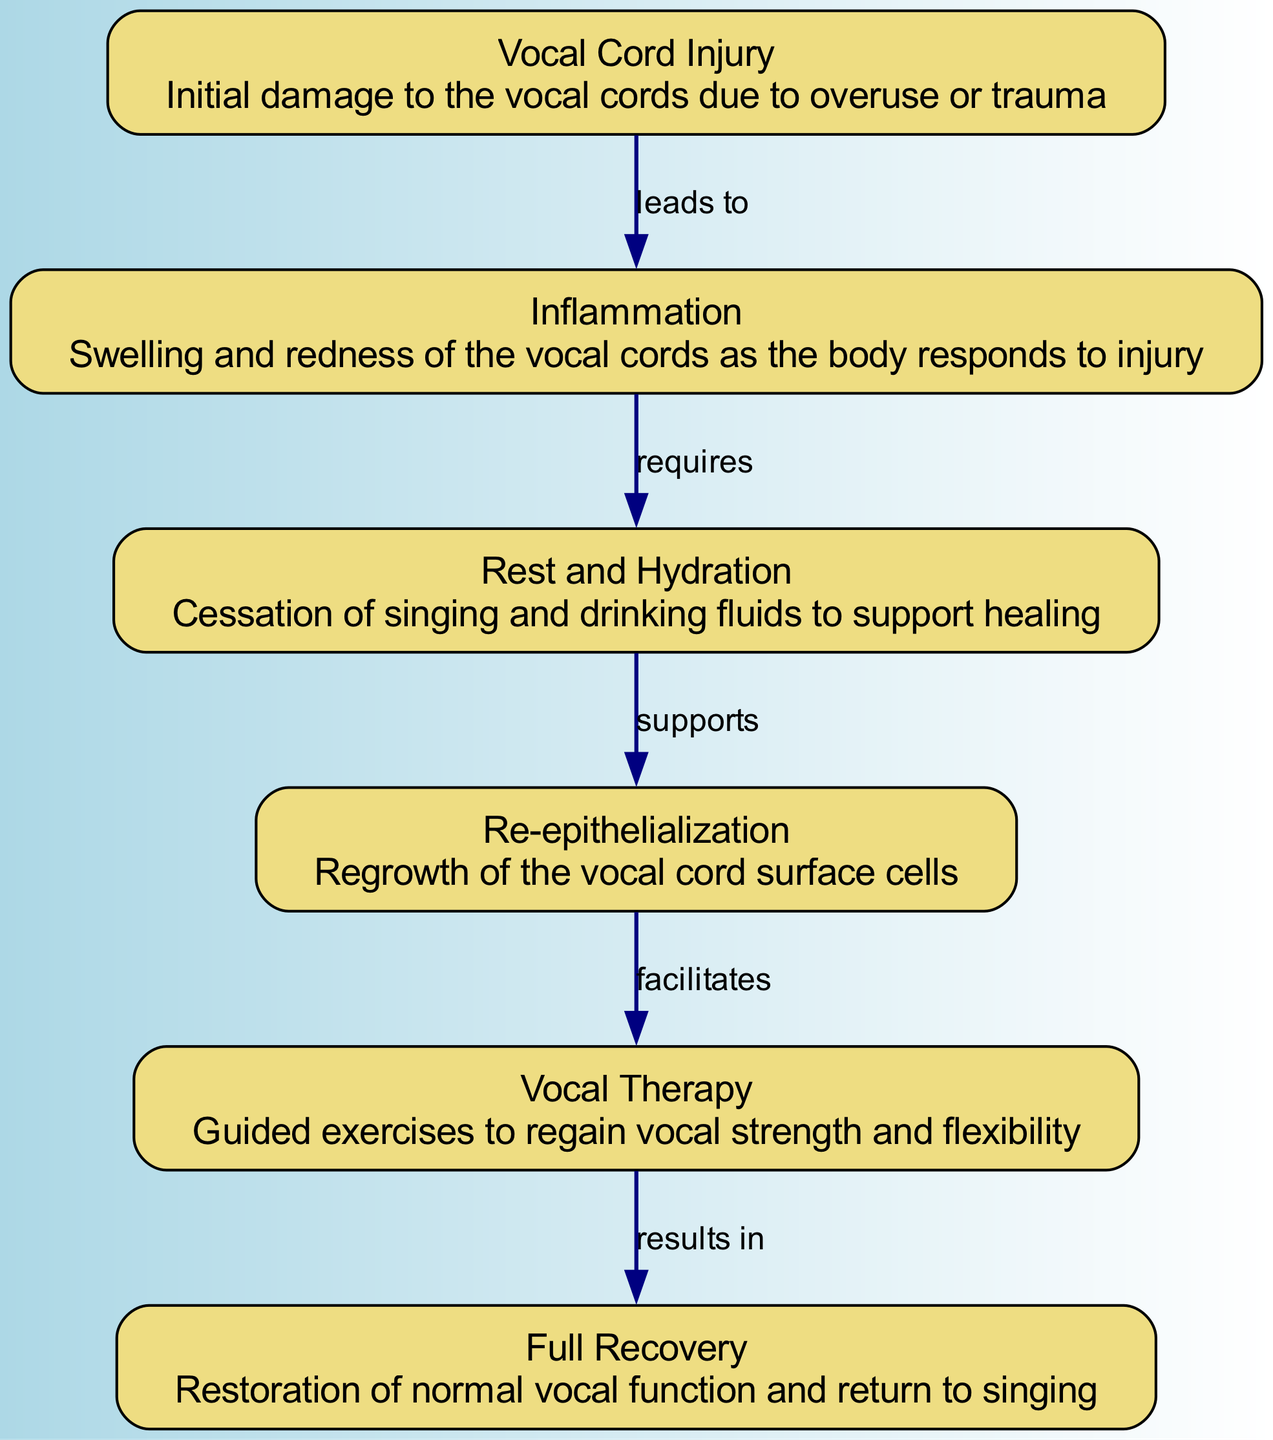What is the first stage of vocal cord healing? The first stage in the diagram is labeled "Vocal Cord Injury," which indicates the initial damage to the vocal cords caused by overuse or trauma.
Answer: Vocal Cord Injury What stage follows Inflammation? According to the diagram, Inflammation leads to the next stage listed, which is "Rest and Hydration."
Answer: Rest and Hydration How many total stages are represented in this diagram? There are six nodes present in the diagram, each representing a different stage in the healing process.
Answer: 6 What type of therapy is recommended after Re-epithelialization? The diagram indicates that after Re-epithelialization, the next stage involves "Vocal Therapy," which includes guided exercises to regain vocal strength and flexibility.
Answer: Vocal Therapy What supports the transition from Rest and Hydration to Re-epithelialization? The diagram shows that Rest and Hydration supports the next stage, which is Re-epithelialization, indicating that proper care and fluid intake contribute to the healing process.
Answer: Re-epithelialization What is the final outcome of the vocal recovery process? The last stage in the diagram is "Full Recovery," which signifies the final outcome of the healing process, restoring normal vocal function and allowing the individual to return to singing.
Answer: Full Recovery Which stage requires the highest level of intervention according to the diagram? The diagram suggests that "Vocal Therapy" involves guided exercises and is a key intervention following the Re-epithelialization stage, indicating a higher level of active engagement.
Answer: Vocal Therapy 